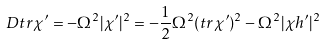<formula> <loc_0><loc_0><loc_500><loc_500>D t r \chi ^ { \prime } = - \Omega ^ { 2 } | \chi ^ { \prime } | ^ { 2 } = - \frac { 1 } { 2 } \Omega ^ { 2 } ( t r \chi ^ { \prime } ) ^ { 2 } - \Omega ^ { 2 } | \chi h ^ { \prime } | ^ { 2 }</formula> 